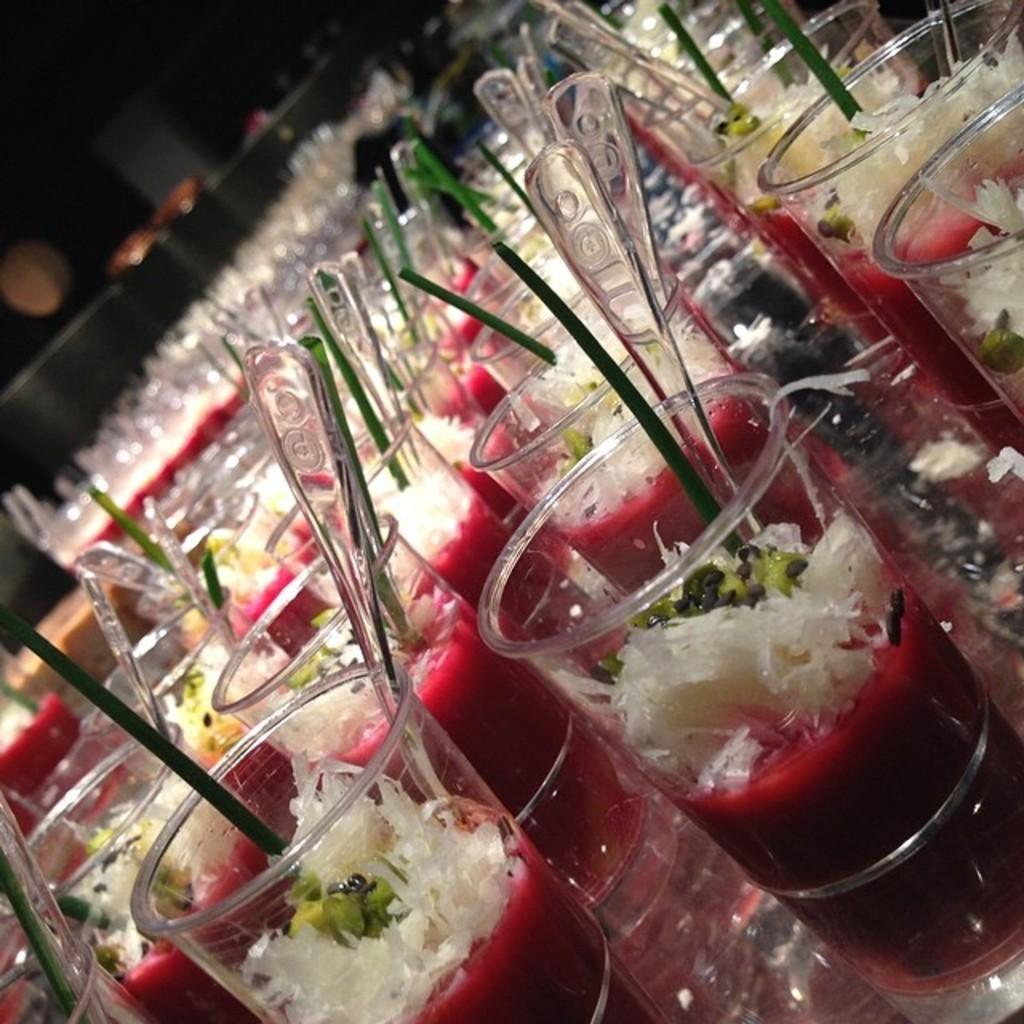What type of food is in the tumblers in the image? There are desserts in the tumblers. What utensils are present on the table in the image? Spoons are placed on the table. How much support does the quarter provide to the desserts in the tumblers? There is no quarter present in the image, so it cannot provide any support to the desserts in the tumblers. 